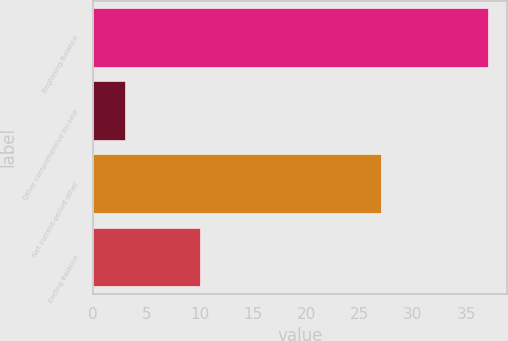<chart> <loc_0><loc_0><loc_500><loc_500><bar_chart><fcel>Beginning Balance<fcel>Other comprehensive income<fcel>Net current-period other<fcel>Ending Balance<nl><fcel>37<fcel>3<fcel>27<fcel>10<nl></chart> 